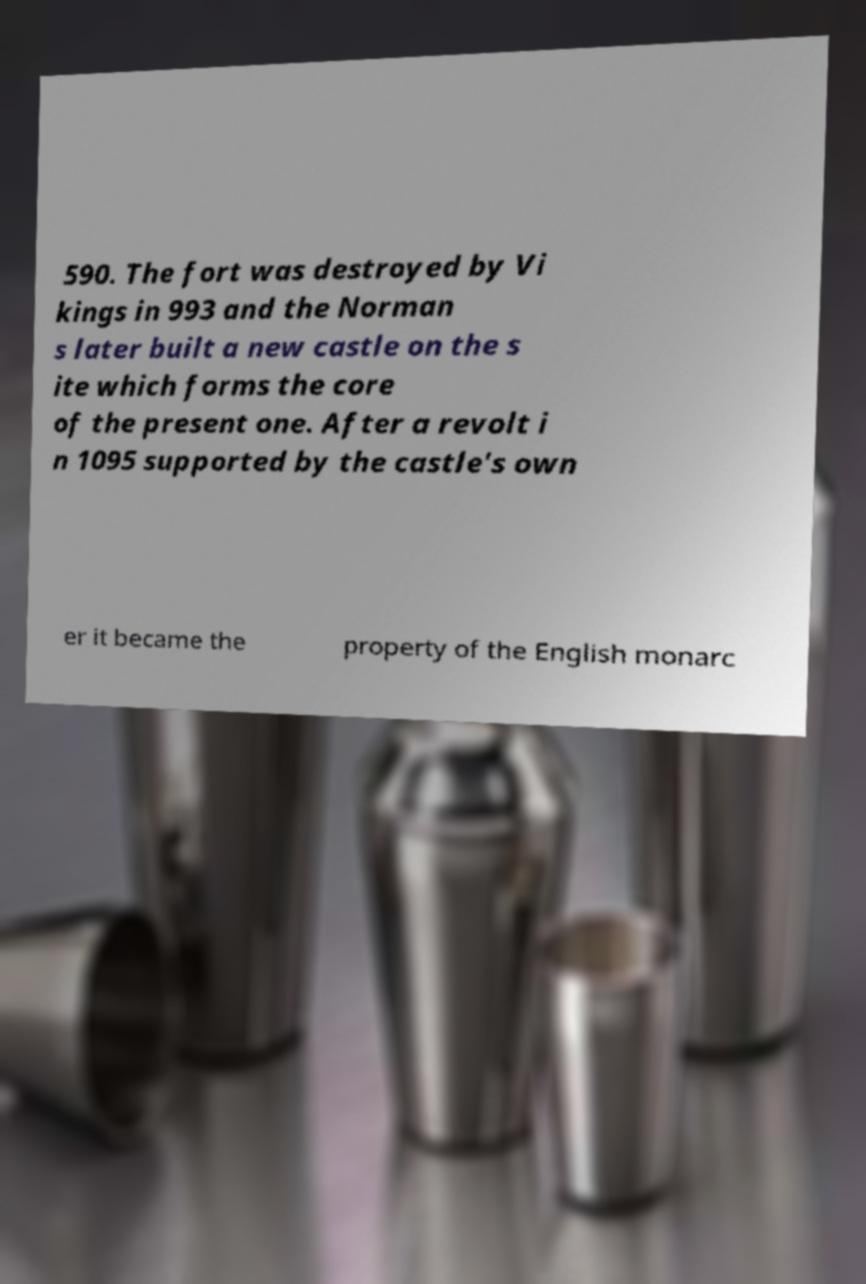There's text embedded in this image that I need extracted. Can you transcribe it verbatim? 590. The fort was destroyed by Vi kings in 993 and the Norman s later built a new castle on the s ite which forms the core of the present one. After a revolt i n 1095 supported by the castle's own er it became the property of the English monarc 